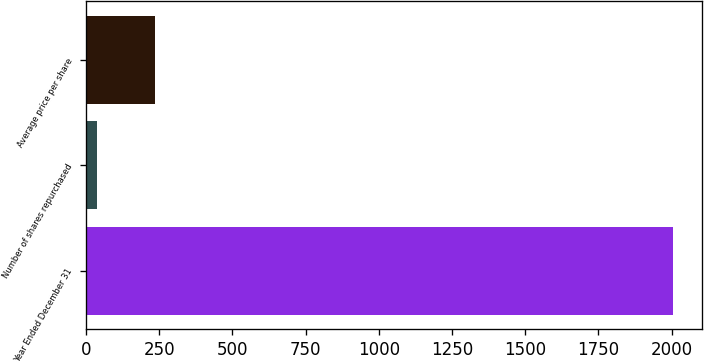Convert chart. <chart><loc_0><loc_0><loc_500><loc_500><bar_chart><fcel>Year Ended December 31<fcel>Number of shares repurchased<fcel>Average price per share<nl><fcel>2004<fcel>38<fcel>234.6<nl></chart> 